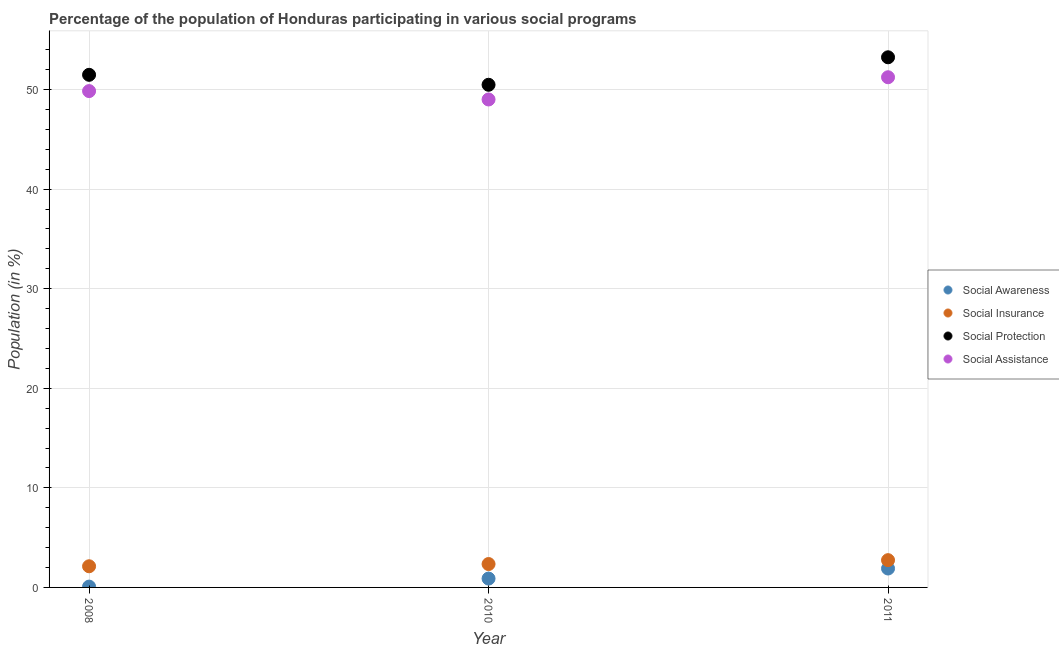What is the participation of population in social awareness programs in 2011?
Your answer should be compact. 1.9. Across all years, what is the maximum participation of population in social protection programs?
Provide a succinct answer. 53.24. Across all years, what is the minimum participation of population in social insurance programs?
Offer a terse response. 2.12. In which year was the participation of population in social awareness programs minimum?
Your answer should be very brief. 2008. What is the total participation of population in social protection programs in the graph?
Provide a short and direct response. 155.21. What is the difference between the participation of population in social assistance programs in 2008 and that in 2010?
Your response must be concise. 0.84. What is the difference between the participation of population in social awareness programs in 2010 and the participation of population in social assistance programs in 2008?
Provide a short and direct response. -48.96. What is the average participation of population in social protection programs per year?
Provide a succinct answer. 51.74. In the year 2010, what is the difference between the participation of population in social insurance programs and participation of population in social protection programs?
Provide a short and direct response. -48.13. What is the ratio of the participation of population in social assistance programs in 2008 to that in 2010?
Keep it short and to the point. 1.02. What is the difference between the highest and the second highest participation of population in social assistance programs?
Keep it short and to the point. 1.39. What is the difference between the highest and the lowest participation of population in social protection programs?
Give a very brief answer. 2.76. Is the sum of the participation of population in social awareness programs in 2008 and 2011 greater than the maximum participation of population in social assistance programs across all years?
Offer a terse response. No. Is it the case that in every year, the sum of the participation of population in social protection programs and participation of population in social insurance programs is greater than the sum of participation of population in social awareness programs and participation of population in social assistance programs?
Your answer should be very brief. Yes. Is it the case that in every year, the sum of the participation of population in social awareness programs and participation of population in social insurance programs is greater than the participation of population in social protection programs?
Your answer should be very brief. No. Does the participation of population in social awareness programs monotonically increase over the years?
Offer a terse response. Yes. Is the participation of population in social insurance programs strictly greater than the participation of population in social awareness programs over the years?
Offer a very short reply. Yes. Is the participation of population in social awareness programs strictly less than the participation of population in social assistance programs over the years?
Your answer should be very brief. Yes. How many dotlines are there?
Give a very brief answer. 4. How many years are there in the graph?
Give a very brief answer. 3. What is the difference between two consecutive major ticks on the Y-axis?
Provide a short and direct response. 10. Are the values on the major ticks of Y-axis written in scientific E-notation?
Provide a succinct answer. No. Does the graph contain grids?
Your answer should be compact. Yes. Where does the legend appear in the graph?
Your response must be concise. Center right. How are the legend labels stacked?
Offer a terse response. Vertical. What is the title of the graph?
Provide a short and direct response. Percentage of the population of Honduras participating in various social programs . What is the label or title of the X-axis?
Offer a terse response. Year. What is the label or title of the Y-axis?
Provide a succinct answer. Population (in %). What is the Population (in %) of Social Awareness in 2008?
Your answer should be compact. 0.08. What is the Population (in %) of Social Insurance in 2008?
Make the answer very short. 2.12. What is the Population (in %) in Social Protection in 2008?
Keep it short and to the point. 51.48. What is the Population (in %) in Social Assistance in 2008?
Offer a terse response. 49.85. What is the Population (in %) in Social Awareness in 2010?
Offer a very short reply. 0.89. What is the Population (in %) in Social Insurance in 2010?
Offer a terse response. 2.35. What is the Population (in %) in Social Protection in 2010?
Your answer should be compact. 50.48. What is the Population (in %) of Social Assistance in 2010?
Your answer should be compact. 49. What is the Population (in %) in Social Awareness in 2011?
Offer a terse response. 1.9. What is the Population (in %) of Social Insurance in 2011?
Offer a terse response. 2.74. What is the Population (in %) in Social Protection in 2011?
Your response must be concise. 53.24. What is the Population (in %) of Social Assistance in 2011?
Your answer should be compact. 51.24. Across all years, what is the maximum Population (in %) in Social Awareness?
Give a very brief answer. 1.9. Across all years, what is the maximum Population (in %) of Social Insurance?
Your answer should be compact. 2.74. Across all years, what is the maximum Population (in %) in Social Protection?
Offer a very short reply. 53.24. Across all years, what is the maximum Population (in %) in Social Assistance?
Give a very brief answer. 51.24. Across all years, what is the minimum Population (in %) of Social Awareness?
Keep it short and to the point. 0.08. Across all years, what is the minimum Population (in %) of Social Insurance?
Give a very brief answer. 2.12. Across all years, what is the minimum Population (in %) in Social Protection?
Offer a very short reply. 50.48. Across all years, what is the minimum Population (in %) in Social Assistance?
Provide a short and direct response. 49. What is the total Population (in %) of Social Awareness in the graph?
Offer a terse response. 2.87. What is the total Population (in %) of Social Insurance in the graph?
Keep it short and to the point. 7.21. What is the total Population (in %) in Social Protection in the graph?
Your response must be concise. 155.21. What is the total Population (in %) of Social Assistance in the graph?
Ensure brevity in your answer.  150.09. What is the difference between the Population (in %) in Social Awareness in 2008 and that in 2010?
Ensure brevity in your answer.  -0.81. What is the difference between the Population (in %) of Social Insurance in 2008 and that in 2010?
Your response must be concise. -0.22. What is the difference between the Population (in %) of Social Protection in 2008 and that in 2010?
Your answer should be compact. 1. What is the difference between the Population (in %) in Social Assistance in 2008 and that in 2010?
Your response must be concise. 0.84. What is the difference between the Population (in %) in Social Awareness in 2008 and that in 2011?
Offer a very short reply. -1.82. What is the difference between the Population (in %) of Social Insurance in 2008 and that in 2011?
Your response must be concise. -0.61. What is the difference between the Population (in %) in Social Protection in 2008 and that in 2011?
Your response must be concise. -1.76. What is the difference between the Population (in %) of Social Assistance in 2008 and that in 2011?
Your response must be concise. -1.39. What is the difference between the Population (in %) in Social Awareness in 2010 and that in 2011?
Ensure brevity in your answer.  -1.01. What is the difference between the Population (in %) in Social Insurance in 2010 and that in 2011?
Ensure brevity in your answer.  -0.39. What is the difference between the Population (in %) in Social Protection in 2010 and that in 2011?
Your answer should be very brief. -2.76. What is the difference between the Population (in %) in Social Assistance in 2010 and that in 2011?
Your answer should be very brief. -2.23. What is the difference between the Population (in %) of Social Awareness in 2008 and the Population (in %) of Social Insurance in 2010?
Your answer should be very brief. -2.27. What is the difference between the Population (in %) in Social Awareness in 2008 and the Population (in %) in Social Protection in 2010?
Keep it short and to the point. -50.4. What is the difference between the Population (in %) of Social Awareness in 2008 and the Population (in %) of Social Assistance in 2010?
Keep it short and to the point. -48.92. What is the difference between the Population (in %) of Social Insurance in 2008 and the Population (in %) of Social Protection in 2010?
Provide a short and direct response. -48.36. What is the difference between the Population (in %) in Social Insurance in 2008 and the Population (in %) in Social Assistance in 2010?
Your response must be concise. -46.88. What is the difference between the Population (in %) of Social Protection in 2008 and the Population (in %) of Social Assistance in 2010?
Your response must be concise. 2.48. What is the difference between the Population (in %) of Social Awareness in 2008 and the Population (in %) of Social Insurance in 2011?
Your answer should be very brief. -2.66. What is the difference between the Population (in %) of Social Awareness in 2008 and the Population (in %) of Social Protection in 2011?
Offer a terse response. -53.16. What is the difference between the Population (in %) of Social Awareness in 2008 and the Population (in %) of Social Assistance in 2011?
Your response must be concise. -51.16. What is the difference between the Population (in %) in Social Insurance in 2008 and the Population (in %) in Social Protection in 2011?
Provide a short and direct response. -51.12. What is the difference between the Population (in %) of Social Insurance in 2008 and the Population (in %) of Social Assistance in 2011?
Offer a terse response. -49.11. What is the difference between the Population (in %) of Social Protection in 2008 and the Population (in %) of Social Assistance in 2011?
Make the answer very short. 0.24. What is the difference between the Population (in %) in Social Awareness in 2010 and the Population (in %) in Social Insurance in 2011?
Provide a succinct answer. -1.85. What is the difference between the Population (in %) in Social Awareness in 2010 and the Population (in %) in Social Protection in 2011?
Ensure brevity in your answer.  -52.35. What is the difference between the Population (in %) in Social Awareness in 2010 and the Population (in %) in Social Assistance in 2011?
Offer a terse response. -50.35. What is the difference between the Population (in %) of Social Insurance in 2010 and the Population (in %) of Social Protection in 2011?
Ensure brevity in your answer.  -50.89. What is the difference between the Population (in %) in Social Insurance in 2010 and the Population (in %) in Social Assistance in 2011?
Your answer should be compact. -48.89. What is the difference between the Population (in %) of Social Protection in 2010 and the Population (in %) of Social Assistance in 2011?
Make the answer very short. -0.76. What is the average Population (in %) in Social Awareness per year?
Provide a succinct answer. 0.96. What is the average Population (in %) in Social Insurance per year?
Your answer should be compact. 2.4. What is the average Population (in %) of Social Protection per year?
Offer a very short reply. 51.74. What is the average Population (in %) in Social Assistance per year?
Your answer should be very brief. 50.03. In the year 2008, what is the difference between the Population (in %) of Social Awareness and Population (in %) of Social Insurance?
Ensure brevity in your answer.  -2.04. In the year 2008, what is the difference between the Population (in %) of Social Awareness and Population (in %) of Social Protection?
Your answer should be very brief. -51.4. In the year 2008, what is the difference between the Population (in %) in Social Awareness and Population (in %) in Social Assistance?
Provide a succinct answer. -49.77. In the year 2008, what is the difference between the Population (in %) of Social Insurance and Population (in %) of Social Protection?
Give a very brief answer. -49.36. In the year 2008, what is the difference between the Population (in %) in Social Insurance and Population (in %) in Social Assistance?
Provide a succinct answer. -47.72. In the year 2008, what is the difference between the Population (in %) in Social Protection and Population (in %) in Social Assistance?
Provide a succinct answer. 1.63. In the year 2010, what is the difference between the Population (in %) of Social Awareness and Population (in %) of Social Insurance?
Give a very brief answer. -1.46. In the year 2010, what is the difference between the Population (in %) of Social Awareness and Population (in %) of Social Protection?
Your answer should be compact. -49.59. In the year 2010, what is the difference between the Population (in %) of Social Awareness and Population (in %) of Social Assistance?
Make the answer very short. -48.12. In the year 2010, what is the difference between the Population (in %) of Social Insurance and Population (in %) of Social Protection?
Give a very brief answer. -48.13. In the year 2010, what is the difference between the Population (in %) of Social Insurance and Population (in %) of Social Assistance?
Give a very brief answer. -46.66. In the year 2010, what is the difference between the Population (in %) of Social Protection and Population (in %) of Social Assistance?
Provide a succinct answer. 1.48. In the year 2011, what is the difference between the Population (in %) in Social Awareness and Population (in %) in Social Insurance?
Offer a very short reply. -0.84. In the year 2011, what is the difference between the Population (in %) of Social Awareness and Population (in %) of Social Protection?
Keep it short and to the point. -51.34. In the year 2011, what is the difference between the Population (in %) of Social Awareness and Population (in %) of Social Assistance?
Provide a short and direct response. -49.34. In the year 2011, what is the difference between the Population (in %) in Social Insurance and Population (in %) in Social Protection?
Your answer should be very brief. -50.5. In the year 2011, what is the difference between the Population (in %) of Social Insurance and Population (in %) of Social Assistance?
Your answer should be compact. -48.5. In the year 2011, what is the difference between the Population (in %) of Social Protection and Population (in %) of Social Assistance?
Keep it short and to the point. 2. What is the ratio of the Population (in %) in Social Awareness in 2008 to that in 2010?
Offer a very short reply. 0.09. What is the ratio of the Population (in %) of Social Insurance in 2008 to that in 2010?
Ensure brevity in your answer.  0.9. What is the ratio of the Population (in %) in Social Protection in 2008 to that in 2010?
Ensure brevity in your answer.  1.02. What is the ratio of the Population (in %) of Social Assistance in 2008 to that in 2010?
Keep it short and to the point. 1.02. What is the ratio of the Population (in %) of Social Awareness in 2008 to that in 2011?
Provide a short and direct response. 0.04. What is the ratio of the Population (in %) in Social Insurance in 2008 to that in 2011?
Your response must be concise. 0.78. What is the ratio of the Population (in %) in Social Protection in 2008 to that in 2011?
Your response must be concise. 0.97. What is the ratio of the Population (in %) in Social Assistance in 2008 to that in 2011?
Your response must be concise. 0.97. What is the ratio of the Population (in %) of Social Awareness in 2010 to that in 2011?
Offer a terse response. 0.47. What is the ratio of the Population (in %) in Social Insurance in 2010 to that in 2011?
Make the answer very short. 0.86. What is the ratio of the Population (in %) in Social Protection in 2010 to that in 2011?
Your answer should be compact. 0.95. What is the ratio of the Population (in %) in Social Assistance in 2010 to that in 2011?
Provide a succinct answer. 0.96. What is the difference between the highest and the second highest Population (in %) of Social Awareness?
Ensure brevity in your answer.  1.01. What is the difference between the highest and the second highest Population (in %) of Social Insurance?
Make the answer very short. 0.39. What is the difference between the highest and the second highest Population (in %) of Social Protection?
Your answer should be compact. 1.76. What is the difference between the highest and the second highest Population (in %) in Social Assistance?
Ensure brevity in your answer.  1.39. What is the difference between the highest and the lowest Population (in %) in Social Awareness?
Your response must be concise. 1.82. What is the difference between the highest and the lowest Population (in %) in Social Insurance?
Keep it short and to the point. 0.61. What is the difference between the highest and the lowest Population (in %) of Social Protection?
Your response must be concise. 2.76. What is the difference between the highest and the lowest Population (in %) of Social Assistance?
Ensure brevity in your answer.  2.23. 